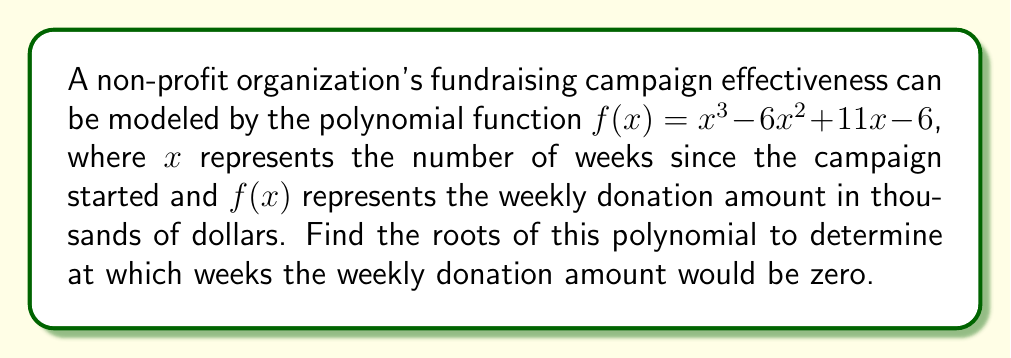Help me with this question. To find the roots of the polynomial $f(x) = x^3 - 6x^2 + 11x - 6$, we need to factor it.

1) First, let's check if there are any rational roots using the rational root theorem. The possible rational roots are the factors of the constant term (6): ±1, ±2, ±3, ±6.

2) Testing these values, we find that $f(1) = 0$. So, $(x-1)$ is a factor.

3) We can use polynomial long division to divide $f(x)$ by $(x-1)$:

   $x^3 - 6x^2 + 11x - 6 = (x-1)(x^2 - 5x + 6)$

4) Now we need to factor the quadratic $x^2 - 5x + 6$. We can do this by finding two numbers that multiply to give 6 and add to give -5. These numbers are -2 and -3.

5) Therefore, $x^2 - 5x + 6 = (x-2)(x-3)$

6) Putting it all together:

   $f(x) = x^3 - 6x^2 + 11x - 6 = (x-1)(x-2)(x-3)$

7) The roots of the polynomial are the values that make each factor equal to zero:
   $x-1 = 0$, $x-2 = 0$, $x-3 = 0$
   So, $x = 1$, $x = 2$, and $x = 3$
Answer: The roots of the polynomial are 1, 2, and 3. This means the weekly donation amount would be zero at 1 week, 2 weeks, and 3 weeks after the start of the campaign. 